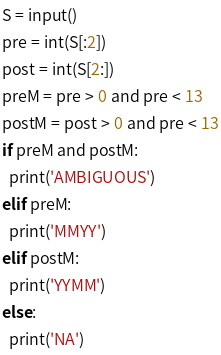<code> <loc_0><loc_0><loc_500><loc_500><_Python_>S = input()
pre = int(S[:2])
post = int(S[2:])
preM = pre > 0 and pre < 13
postM = post > 0 and pre < 13
if preM and postM:
  print('AMBIGUOUS')
elif preM:
  print('MMYY')
elif postM:
  print('YYMM')
else:
  print('NA')</code> 